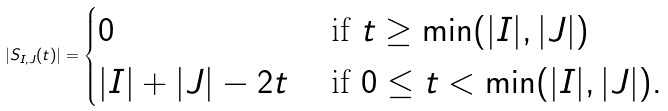Convert formula to latex. <formula><loc_0><loc_0><loc_500><loc_500>| S _ { I , J } ( t ) | = \begin{cases} 0 & \text { if } t \geq \min ( | I | , | J | ) \\ | I | + | J | - 2 t & \text { if } 0 \leq t < \min ( | I | , | J | ) . \end{cases}</formula> 